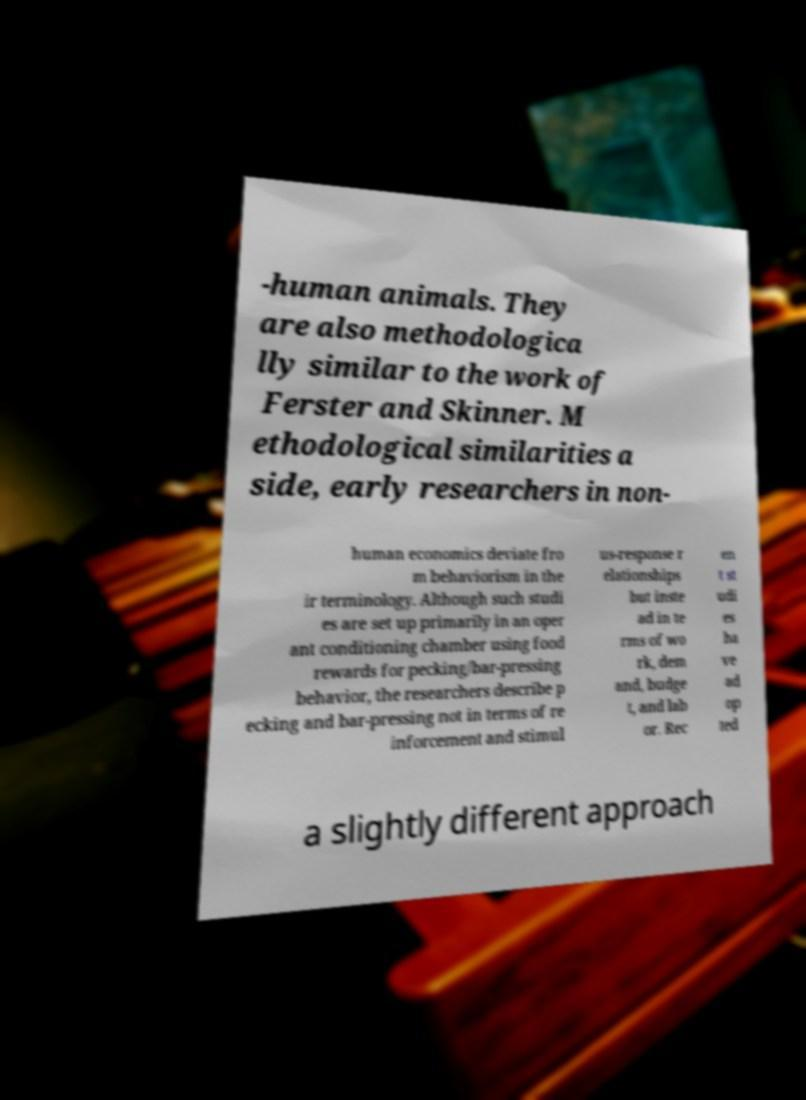Can you read and provide the text displayed in the image?This photo seems to have some interesting text. Can you extract and type it out for me? -human animals. They are also methodologica lly similar to the work of Ferster and Skinner. M ethodological similarities a side, early researchers in non- human economics deviate fro m behaviorism in the ir terminology. Although such studi es are set up primarily in an oper ant conditioning chamber using food rewards for pecking/bar-pressing behavior, the researchers describe p ecking and bar-pressing not in terms of re inforcement and stimul us-response r elationships but inste ad in te rms of wo rk, dem and, budge t, and lab or. Rec en t st udi es ha ve ad op ted a slightly different approach 